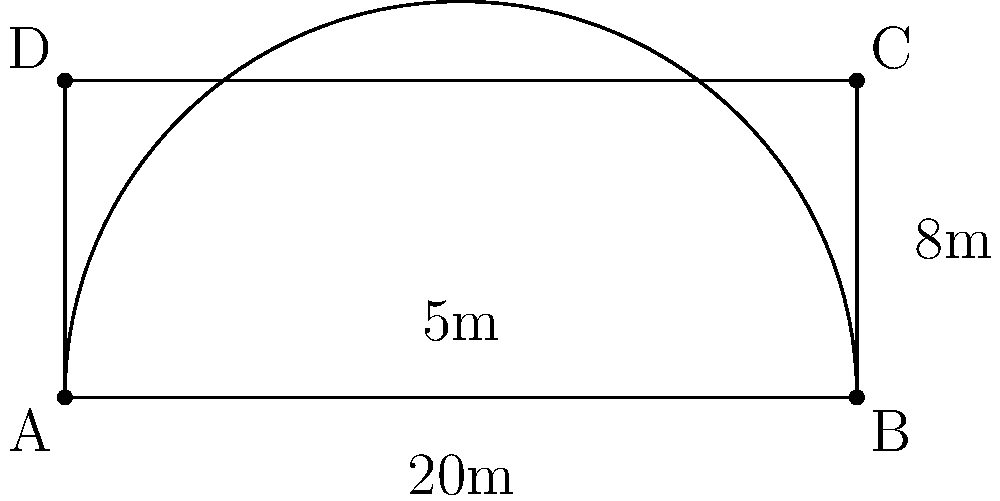As a professional classical piano player, you're designing a new concert hall stage. The stage has a rectangular base with a semicircular front, as shown in the diagram. If the width of the stage is 20 meters and the depth is 8 meters, what is the perimeter of the entire stage? Let's approach this step-by-step:

1) The stage consists of a rectangle with a semicircle attached to one side.

2) For the rectangular part:
   - Width = 20 m
   - Depth = 8 m

3) The perimeter of the stage will include:
   - The two sides of the rectangle
   - The back of the rectangle
   - The semicircular front

4) Calculate the length of the rectangular sides:
   $2 \times 8 \text{ m} = 16 \text{ m}$

5) The back of the rectangle is equal to the width:
   $20 \text{ m}$

6) For the semicircular front:
   - The diameter of the semicircle is equal to the width of the stage (20 m)
   - The radius is therefore 10 m
   - The length of a semicircle is given by the formula: $\pi r$
   - So, the length of the semicircular front is:
     $\pi \times 10 \text{ m} = 10\pi \text{ m}$

7) Now, add all these parts together:
   $\text{Perimeter} = 16 \text{ m} + 20 \text{ m} + 10\pi \text{ m}$

8) Simplify:
   $\text{Perimeter} = 36 + 10\pi \text{ m}$

Therefore, the perimeter of the stage is $36 + 10\pi$ meters.
Answer: $36 + 10\pi$ meters 